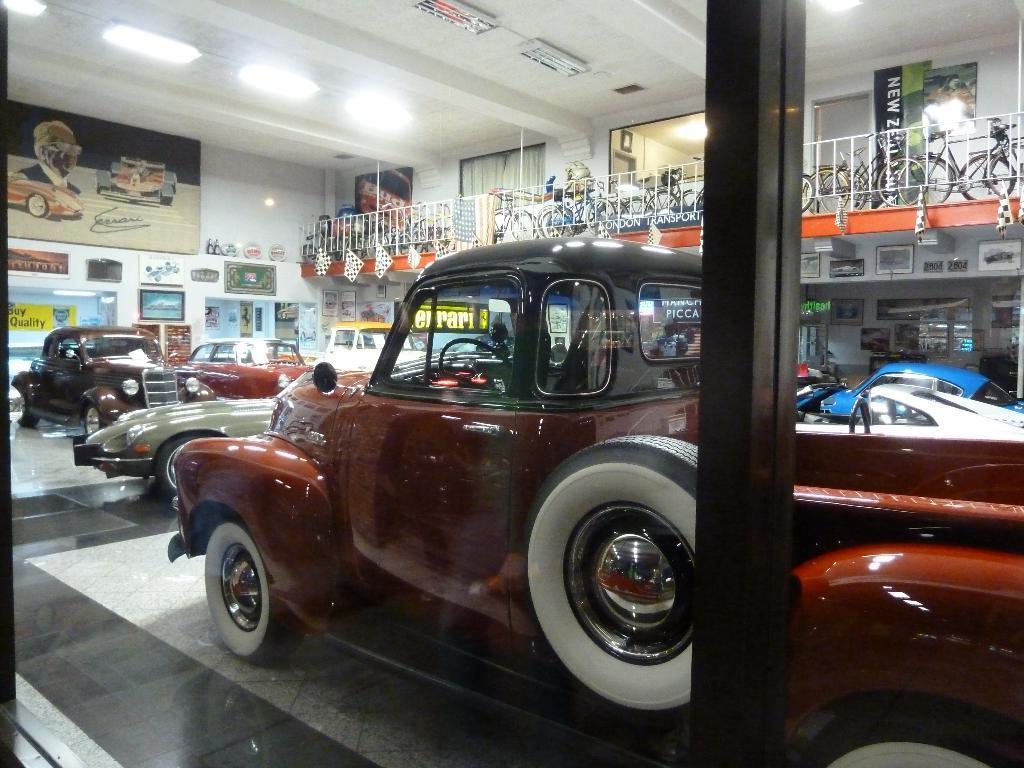Please provide a concise description of this image. In the picture we can see a floor with a vintage car and in the background, we can see a wall with some posters and photo frames and top of the wall we can see a railing and some bicycles are placed and to the ceiling we can see the lights. 